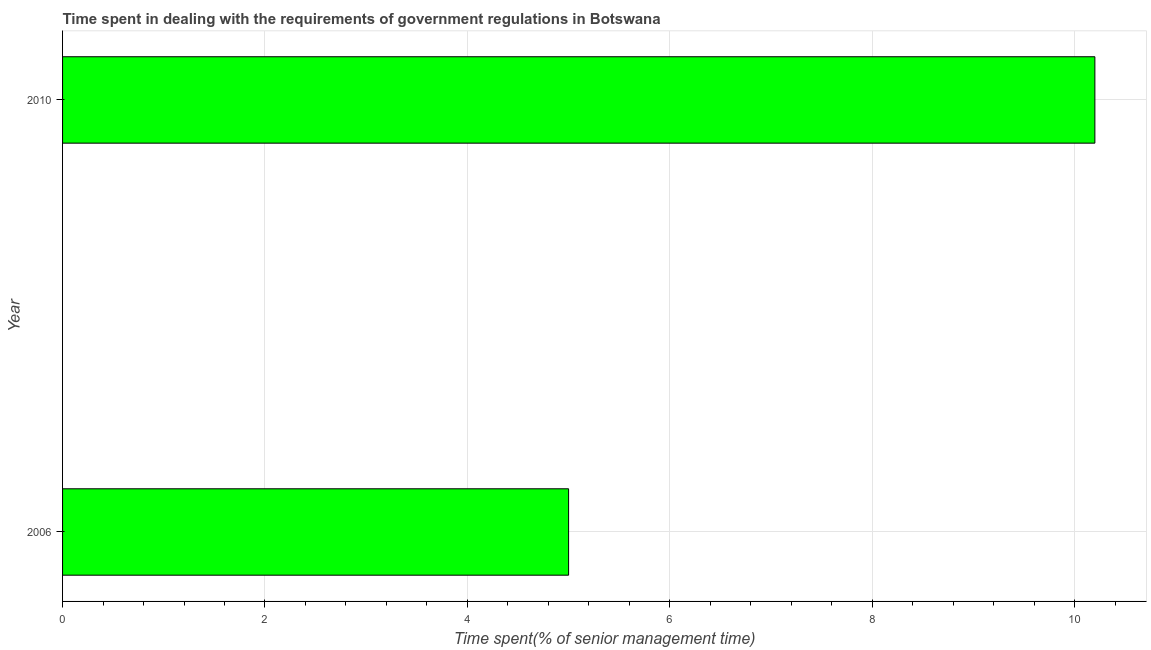Does the graph contain any zero values?
Provide a short and direct response. No. Does the graph contain grids?
Give a very brief answer. Yes. What is the title of the graph?
Ensure brevity in your answer.  Time spent in dealing with the requirements of government regulations in Botswana. What is the label or title of the X-axis?
Your answer should be very brief. Time spent(% of senior management time). What is the label or title of the Y-axis?
Make the answer very short. Year. Across all years, what is the maximum time spent in dealing with government regulations?
Make the answer very short. 10.2. In which year was the time spent in dealing with government regulations minimum?
Your answer should be very brief. 2006. What is the sum of the time spent in dealing with government regulations?
Your answer should be compact. 15.2. What is the difference between the time spent in dealing with government regulations in 2006 and 2010?
Provide a short and direct response. -5.2. What is the average time spent in dealing with government regulations per year?
Provide a short and direct response. 7.6. What is the median time spent in dealing with government regulations?
Make the answer very short. 7.6. What is the ratio of the time spent in dealing with government regulations in 2006 to that in 2010?
Provide a short and direct response. 0.49. Is the time spent in dealing with government regulations in 2006 less than that in 2010?
Provide a succinct answer. Yes. How many bars are there?
Offer a terse response. 2. What is the difference between two consecutive major ticks on the X-axis?
Offer a very short reply. 2. What is the Time spent(% of senior management time) in 2010?
Your response must be concise. 10.2. What is the ratio of the Time spent(% of senior management time) in 2006 to that in 2010?
Provide a short and direct response. 0.49. 